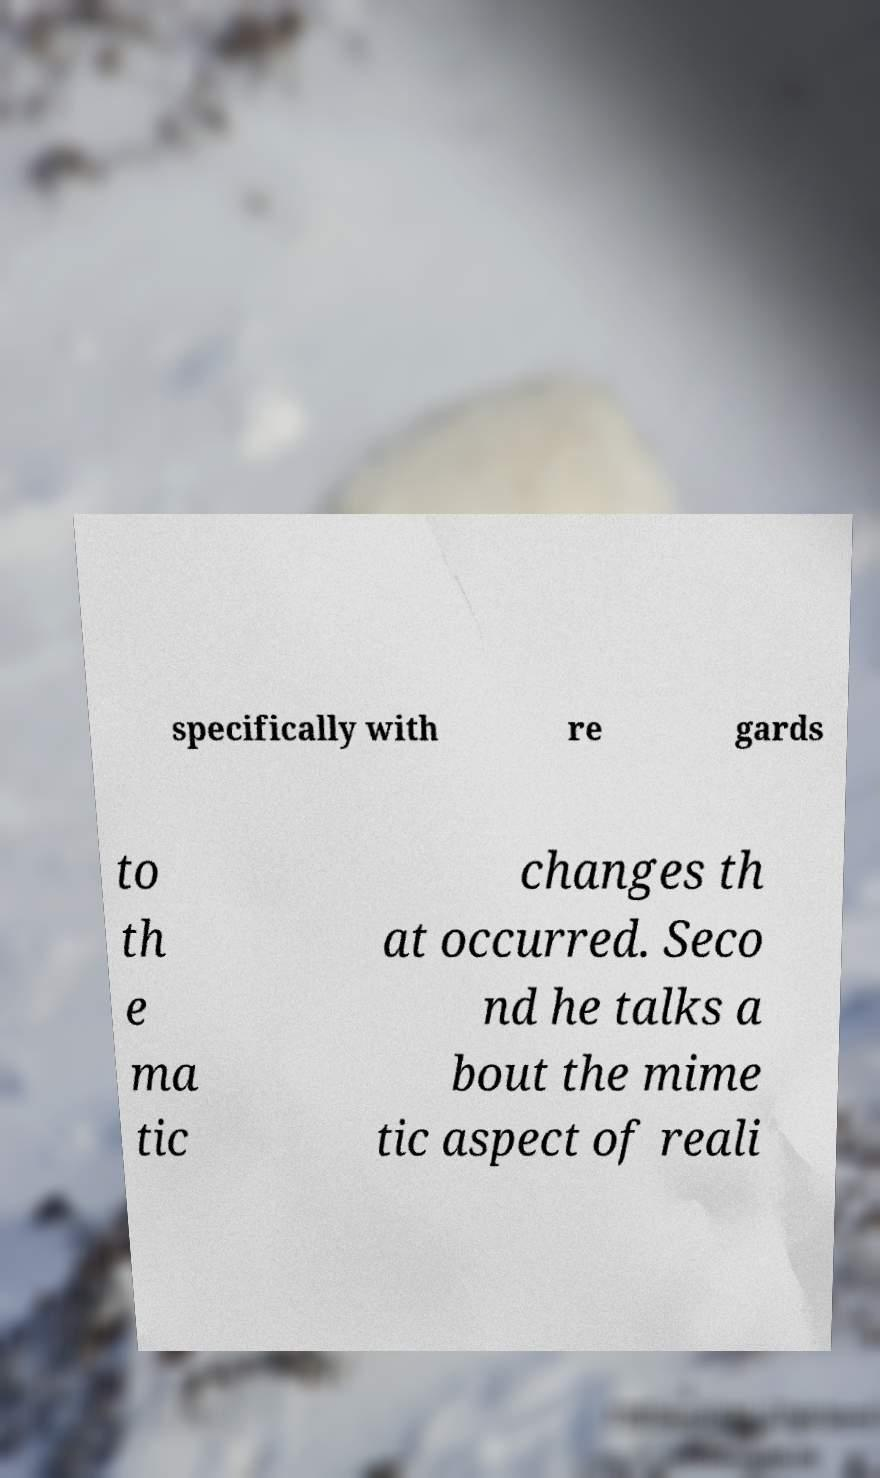Please identify and transcribe the text found in this image. specifically with re gards to th e ma tic changes th at occurred. Seco nd he talks a bout the mime tic aspect of reali 